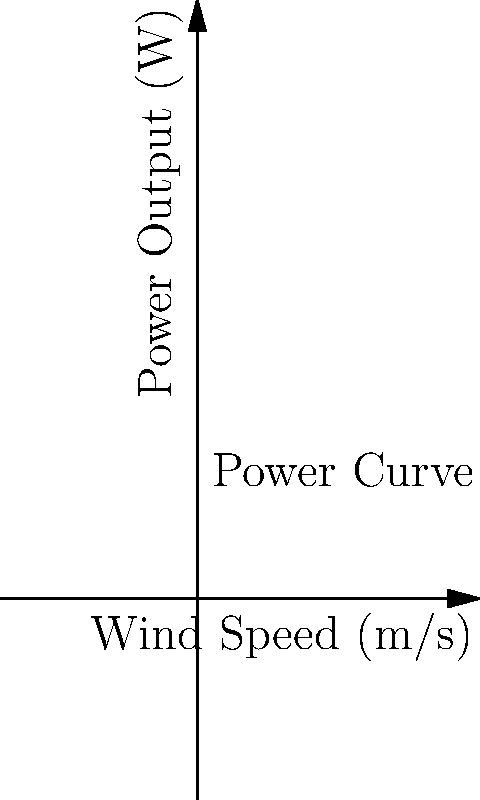A wind turbine has blades with a diameter of 50 meters and operates with a power coefficient of 0.4. If the wind speed is 15 m/s, what is the power output of the turbine in megawatts (MW)? Assume air density is 1.225 kg/m³. Round your answer to two decimal places. To calculate the power output of a wind turbine, we'll use the wind power equation:

$$ P = \frac{1}{2} \rho A C_p v^3 $$

Where:
- $P$ is the power output in watts (W)
- $\rho$ is the air density (1.225 kg/m³)
- $A$ is the swept area of the turbine blades in m²
- $C_p$ is the power coefficient (0.4)
- $v$ is the wind speed in m/s

Step 1: Calculate the swept area $A$
$$ A = \pi r^2 = \pi (25 \text{ m})^2 = 1963.5 \text{ m}^2 $$

Step 2: Plug all values into the equation
$$ P = \frac{1}{2} (1.225 \text{ kg/m}^3) (1963.5 \text{ m}^2) (0.4) (15 \text{ m/s})^3 $$

Step 3: Calculate the result
$$ P = 2,004,096.09 \text{ W} = 2.00 \text{ MW} $$

Therefore, the power output of the wind turbine is 2.00 MW.
Answer: 2.00 MW 